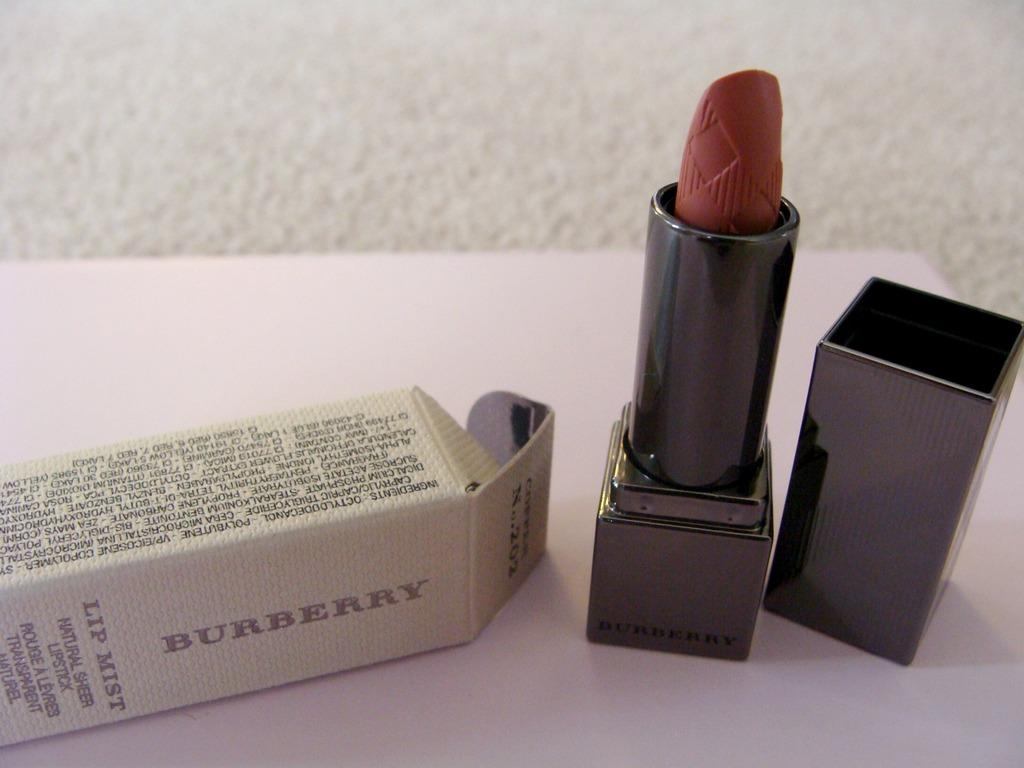<image>
Relay a brief, clear account of the picture shown. A Burberry lipstick in a dark shade and the box it came out of. 